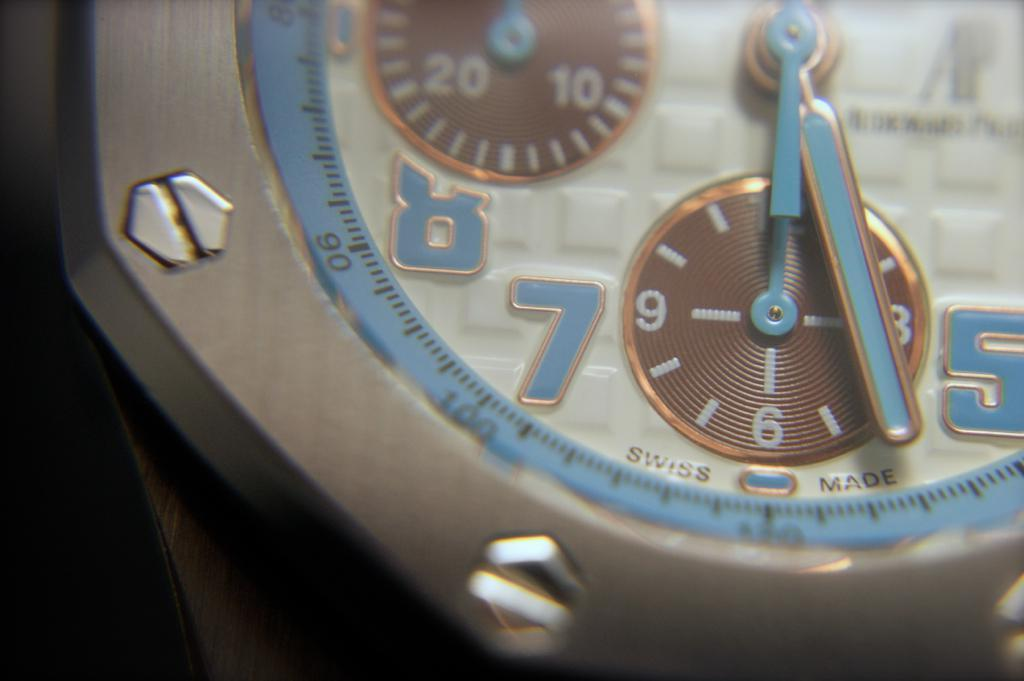Provide a one-sentence caption for the provided image. Face of a watch which says SWISS MADE on it. 